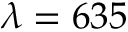Convert formula to latex. <formula><loc_0><loc_0><loc_500><loc_500>\lambda = 6 3 5</formula> 